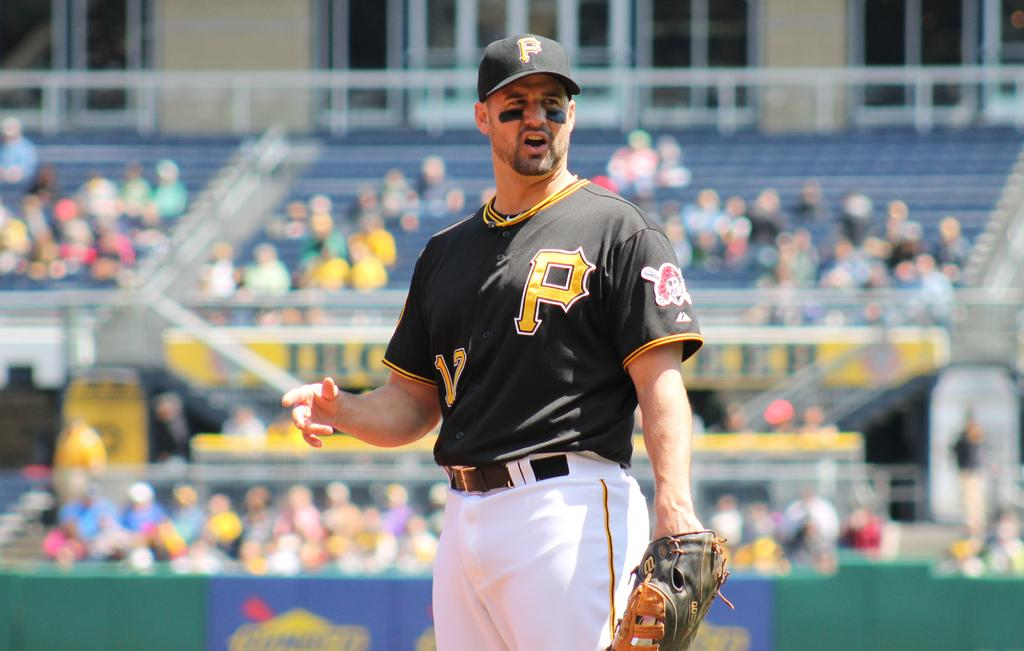<image>
Provide a brief description of the given image. A baseball player is wearing a black shirt with a yellow P on it. 